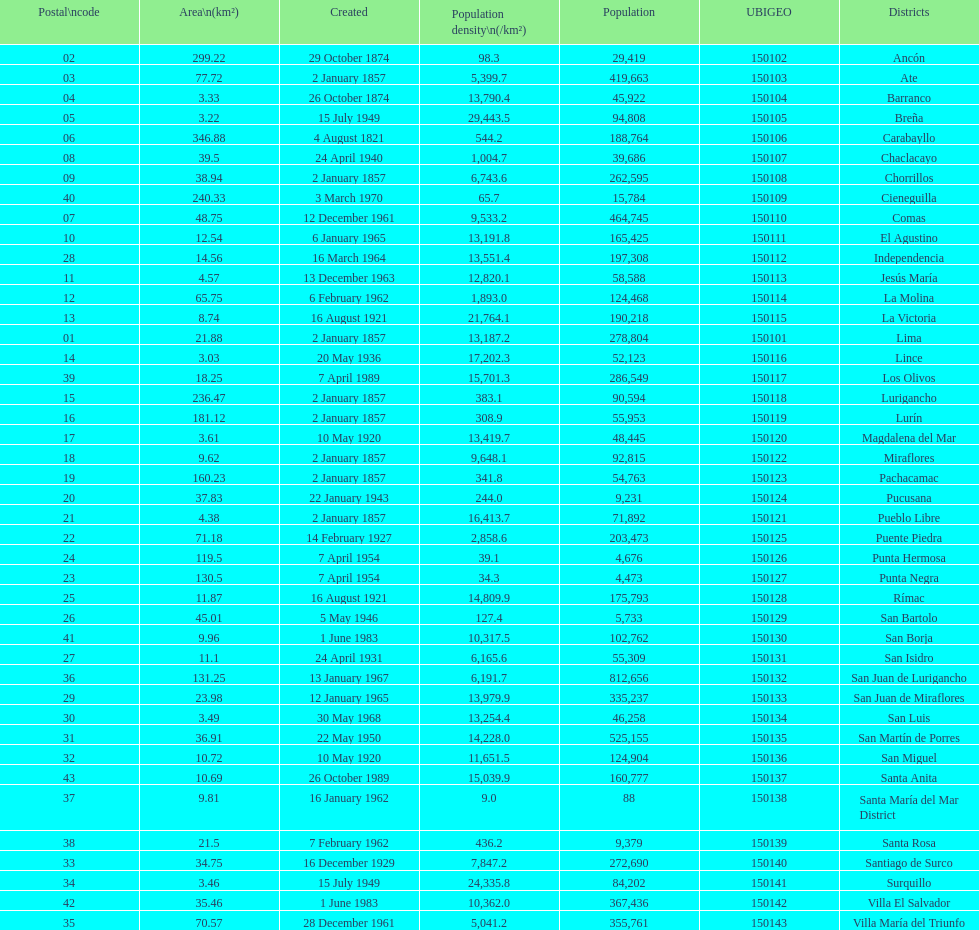How many districts have more than 100,000 people in this city? 21. 